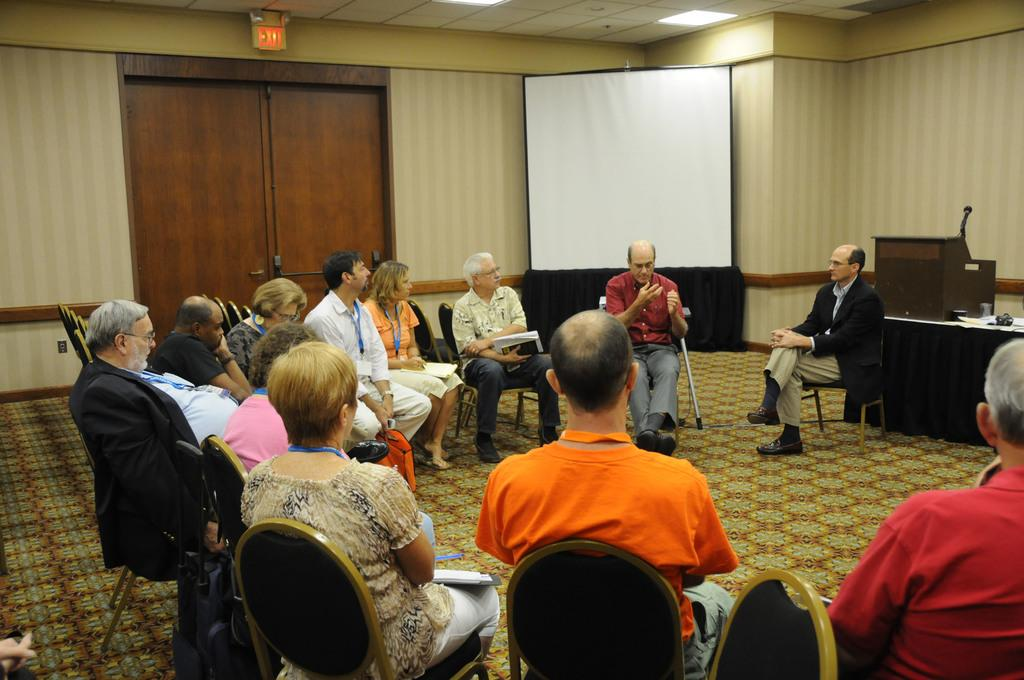What types of people are in the image? There are men and women in the image. What are the men and women doing in the image? They appear to be sitting on chairs and discussing something. What can be seen in the background of the image? There is a wooden door and a white projector screen in the background of the image. What color is the donkey's hair in the image? There is no donkey present in the image, so it is not possible to determine the color of its hair. 